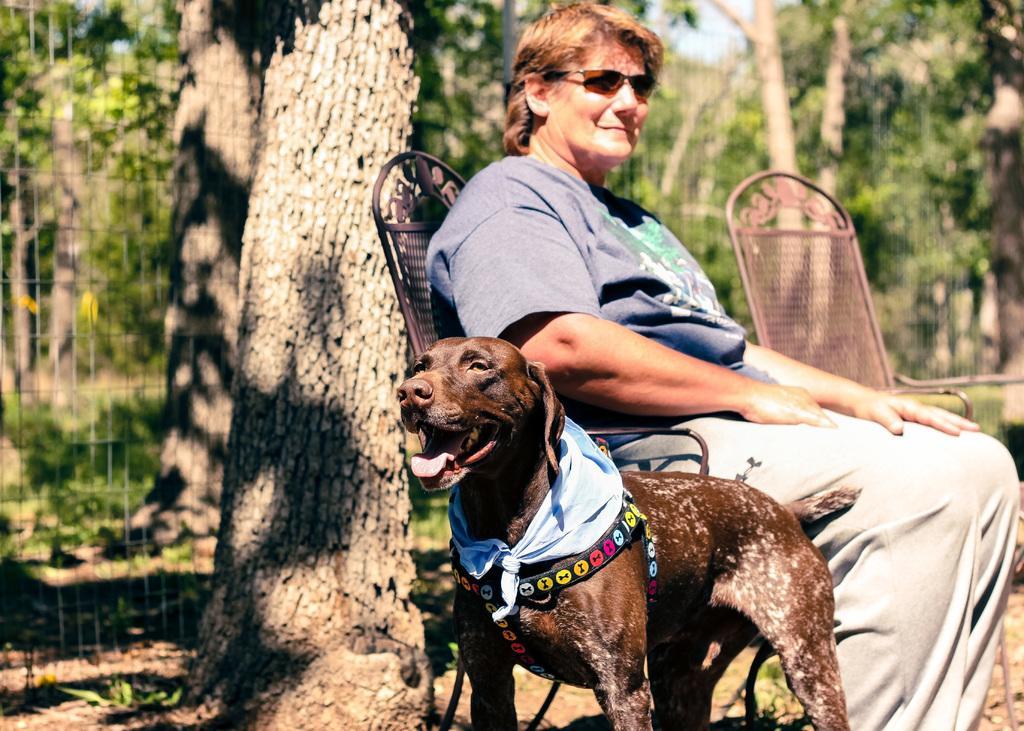Could you give a brief overview of what you see in this image? In this image there is a woman sitting in the chair, Beside the chair there is a dog. In the background there is a tree. Beside the tree there is a net. There is a belt and kerchief tied to the dogs neck. On the right side there is another chair. In the background there are trees. 